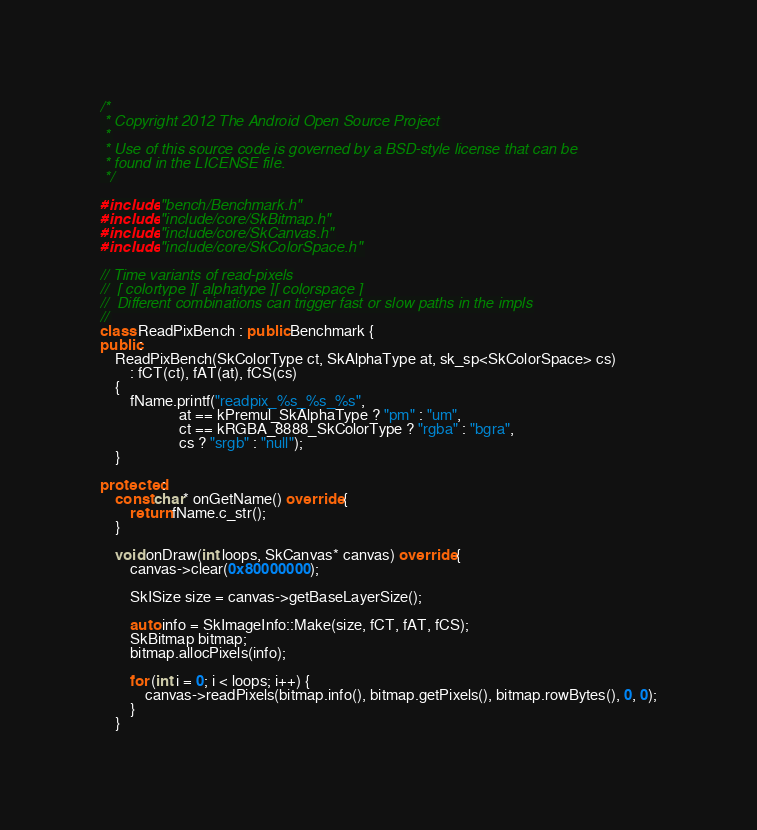Convert code to text. <code><loc_0><loc_0><loc_500><loc_500><_C++_>/*
 * Copyright 2012 The Android Open Source Project
 *
 * Use of this source code is governed by a BSD-style license that can be
 * found in the LICENSE file.
 */

#include "bench/Benchmark.h"
#include "include/core/SkBitmap.h"
#include "include/core/SkCanvas.h"
#include "include/core/SkColorSpace.h"

// Time variants of read-pixels
//  [ colortype ][ alphatype ][ colorspace ]
//  Different combinations can trigger fast or slow paths in the impls
//
class ReadPixBench : public Benchmark {
public:
    ReadPixBench(SkColorType ct, SkAlphaType at, sk_sp<SkColorSpace> cs)
        : fCT(ct), fAT(at), fCS(cs)
    {
        fName.printf("readpix_%s_%s_%s",
                     at == kPremul_SkAlphaType ? "pm" : "um",
                     ct == kRGBA_8888_SkColorType ? "rgba" : "bgra",
                     cs ? "srgb" : "null");
    }

protected:
    const char* onGetName() override {
        return fName.c_str();
    }

    void onDraw(int loops, SkCanvas* canvas) override {
        canvas->clear(0x80000000);

        SkISize size = canvas->getBaseLayerSize();

        auto info = SkImageInfo::Make(size, fCT, fAT, fCS);
        SkBitmap bitmap;
        bitmap.allocPixels(info);

        for (int i = 0; i < loops; i++) {
            canvas->readPixels(bitmap.info(), bitmap.getPixels(), bitmap.rowBytes(), 0, 0);
        }
    }
</code> 